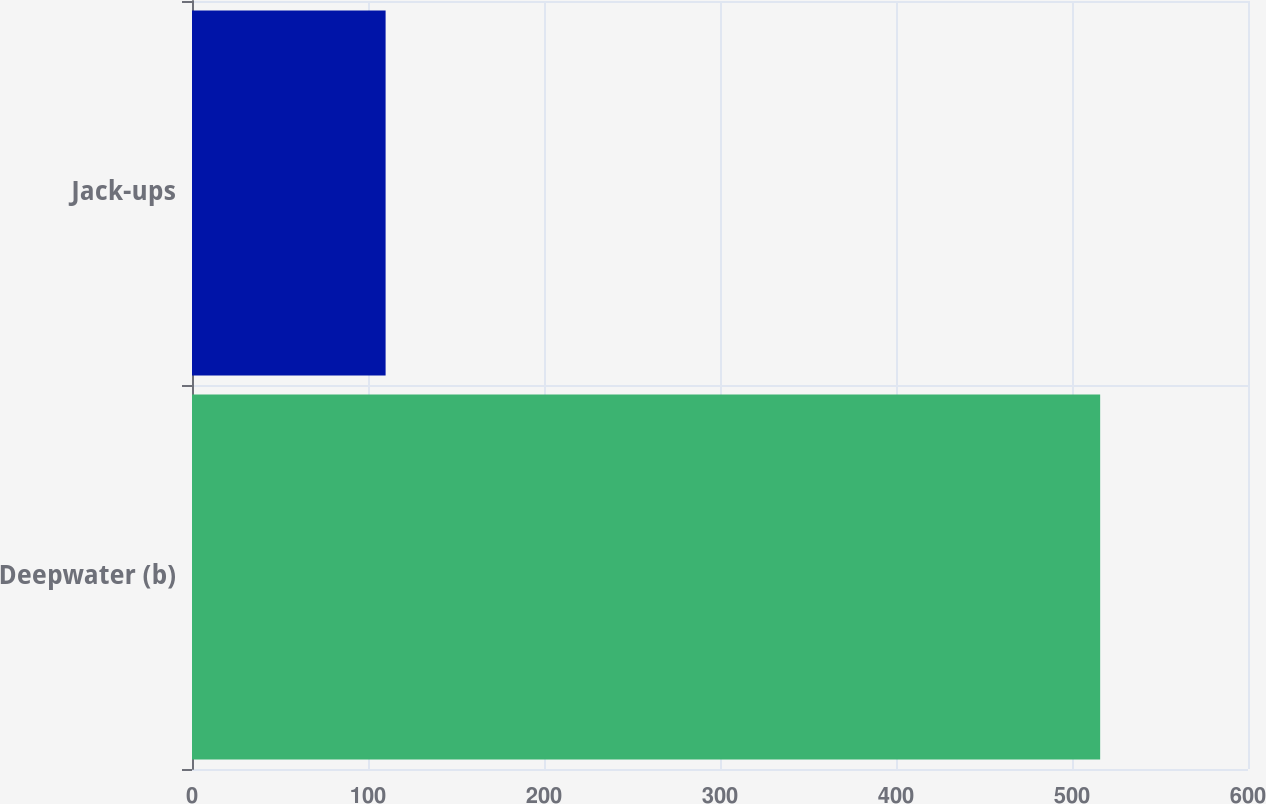<chart> <loc_0><loc_0><loc_500><loc_500><bar_chart><fcel>Deepwater (b)<fcel>Jack-ups<nl><fcel>516<fcel>110<nl></chart> 